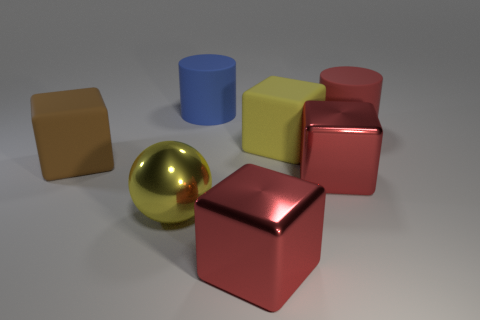Are there fewer metallic objects that are behind the large brown thing than metallic things that are in front of the big yellow shiny ball?
Your response must be concise. Yes. What number of other objects are the same shape as the yellow matte object?
Your answer should be compact. 3. Is the number of big yellow rubber things behind the large yellow matte block less than the number of brown metallic blocks?
Offer a very short reply. No. There is a big cylinder that is behind the red cylinder; what material is it?
Ensure brevity in your answer.  Rubber. What number of other objects are the same size as the yellow matte object?
Make the answer very short. 6. Is the number of large brown cylinders less than the number of big blue cylinders?
Keep it short and to the point. Yes. There is a brown rubber thing; what shape is it?
Offer a very short reply. Cube. There is a cube that is in front of the big yellow sphere; is its color the same as the shiny sphere?
Your response must be concise. No. The matte object that is both in front of the large red cylinder and right of the shiny sphere has what shape?
Provide a short and direct response. Cube. What color is the cylinder that is on the right side of the big yellow rubber object?
Provide a succinct answer. Red. 